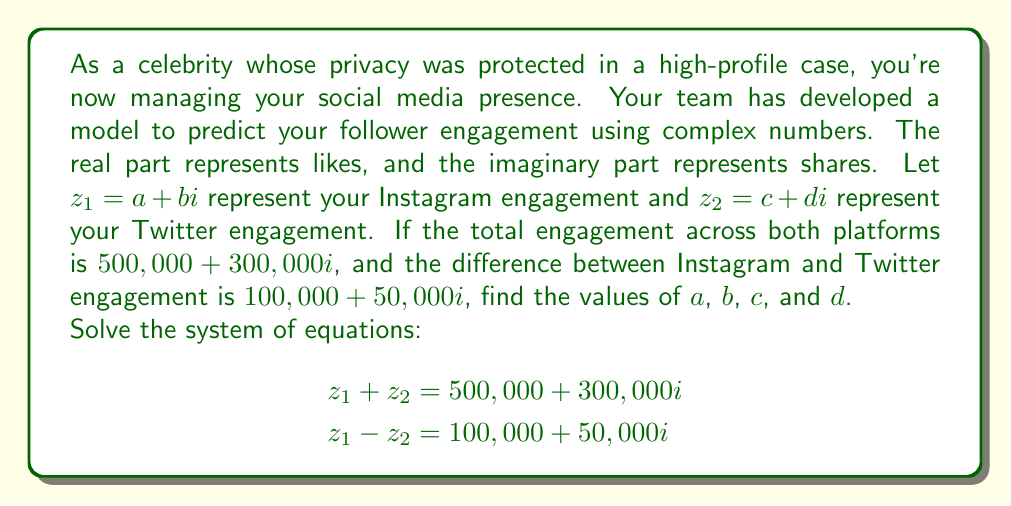Give your solution to this math problem. Let's approach this step-by-step:

1) We have two equations:
   $$z_1 + z_2 = 500,000 + 300,000i$$
   $$z_1 - z_2 = 100,000 + 50,000i$$

2) Substitute $z_1 = a + bi$ and $z_2 = c + di$:
   $$(a + bi) + (c + di) = 500,000 + 300,000i$$
   $$(a + bi) - (c + di) = 100,000 + 50,000i$$

3) From the first equation:
   $$(a + c) + (b + d)i = 500,000 + 300,000i$$
   
   This gives us two equations:
   $$a + c = 500,000$$
   $$b + d = 300,000$$

4) From the second equation:
   $$(a - c) + (b - d)i = 100,000 + 50,000i$$
   
   This gives us two more equations:
   $$a - c = 100,000$$
   $$b - d = 50,000$$

5) Now we have a system of 4 equations:
   $$a + c = 500,000$$
   $$b + d = 300,000$$
   $$a - c = 100,000$$
   $$b - d = 50,000$$

6) Add the equations $a + c = 500,000$ and $a - c = 100,000$:
   $$2a = 600,000$$
   $$a = 300,000$$

7) Subtract $a - c = 100,000$ from $a + c = 500,000$:
   $$2c = 400,000$$
   $$c = 200,000$$

8) Similarly for $b$ and $d$:
   $$2b = 350,000$$
   $$b = 175,000$$
   
   $$2d = 250,000$$
   $$d = 125,000$$

Therefore, we have found the values of $a$, $b$, $c$, and $d$.
Answer: $a = 300,000$, $b = 175,000$, $c = 200,000$, $d = 125,000$

Instagram engagement: $z_1 = 300,000 + 175,000i$
Twitter engagement: $z_2 = 200,000 + 125,000i$ 